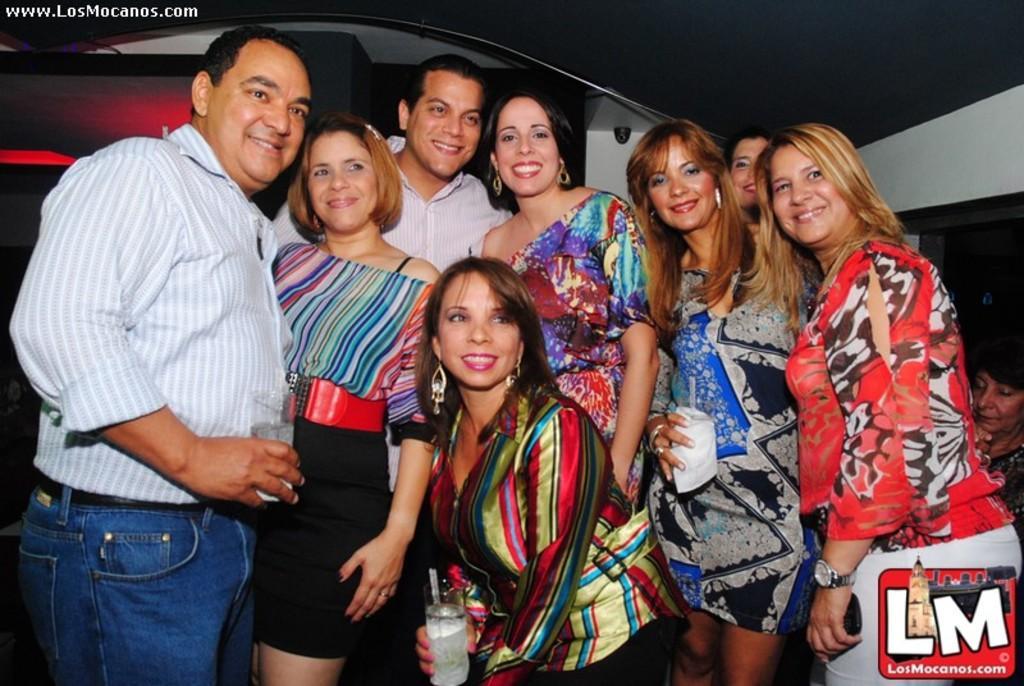Can you describe this image briefly? In this picture, we can see a few people and a few are holding some objects, and we can see the background, we can see some watermark in the bottom right corner, and some text on top left corner. 